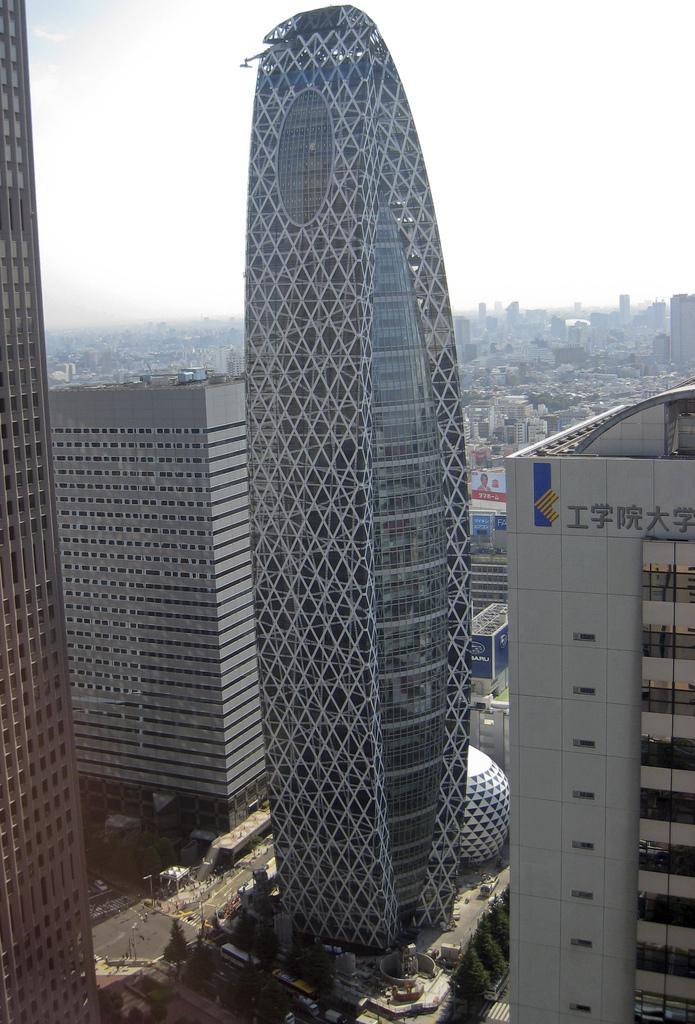In one or two sentences, can you explain what this image depicts? In this picture I can observe buildings in the middle of the picture. In the bottom of the picture I can observe roads. In the background there is sky. 